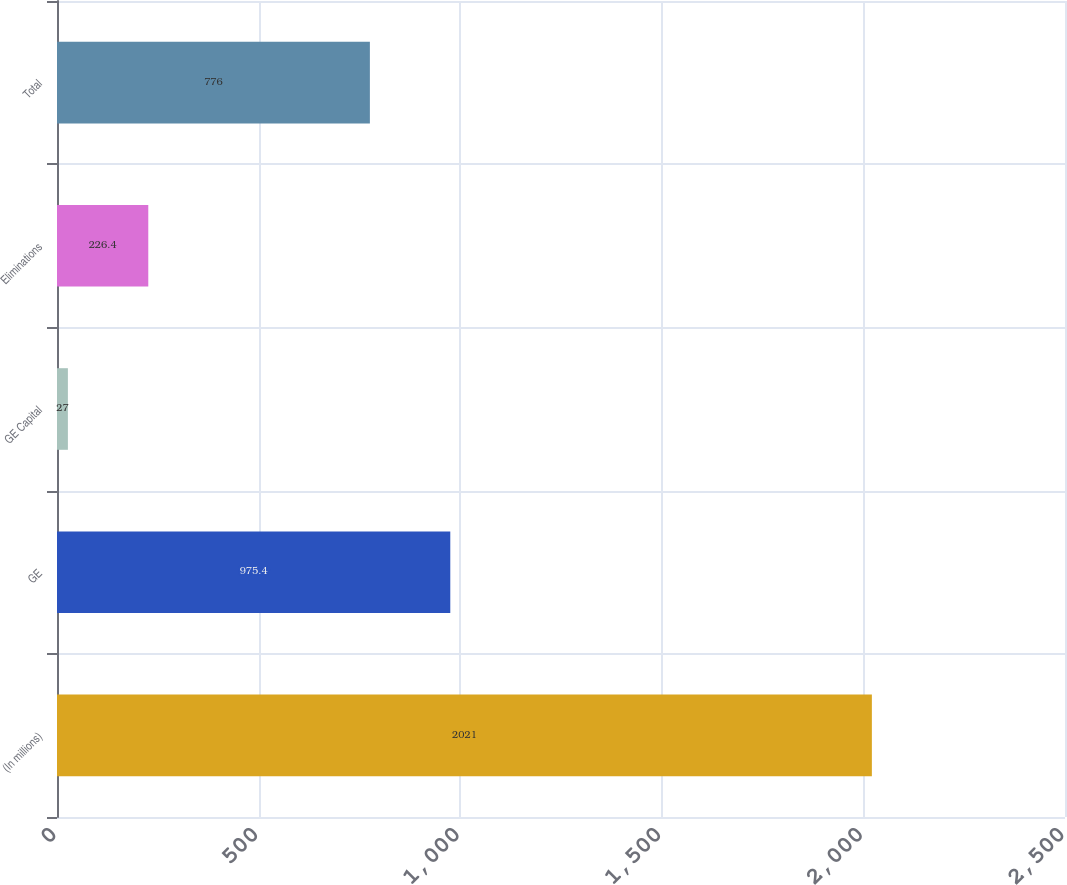Convert chart to OTSL. <chart><loc_0><loc_0><loc_500><loc_500><bar_chart><fcel>(In millions)<fcel>GE<fcel>GE Capital<fcel>Eliminations<fcel>Total<nl><fcel>2021<fcel>975.4<fcel>27<fcel>226.4<fcel>776<nl></chart> 